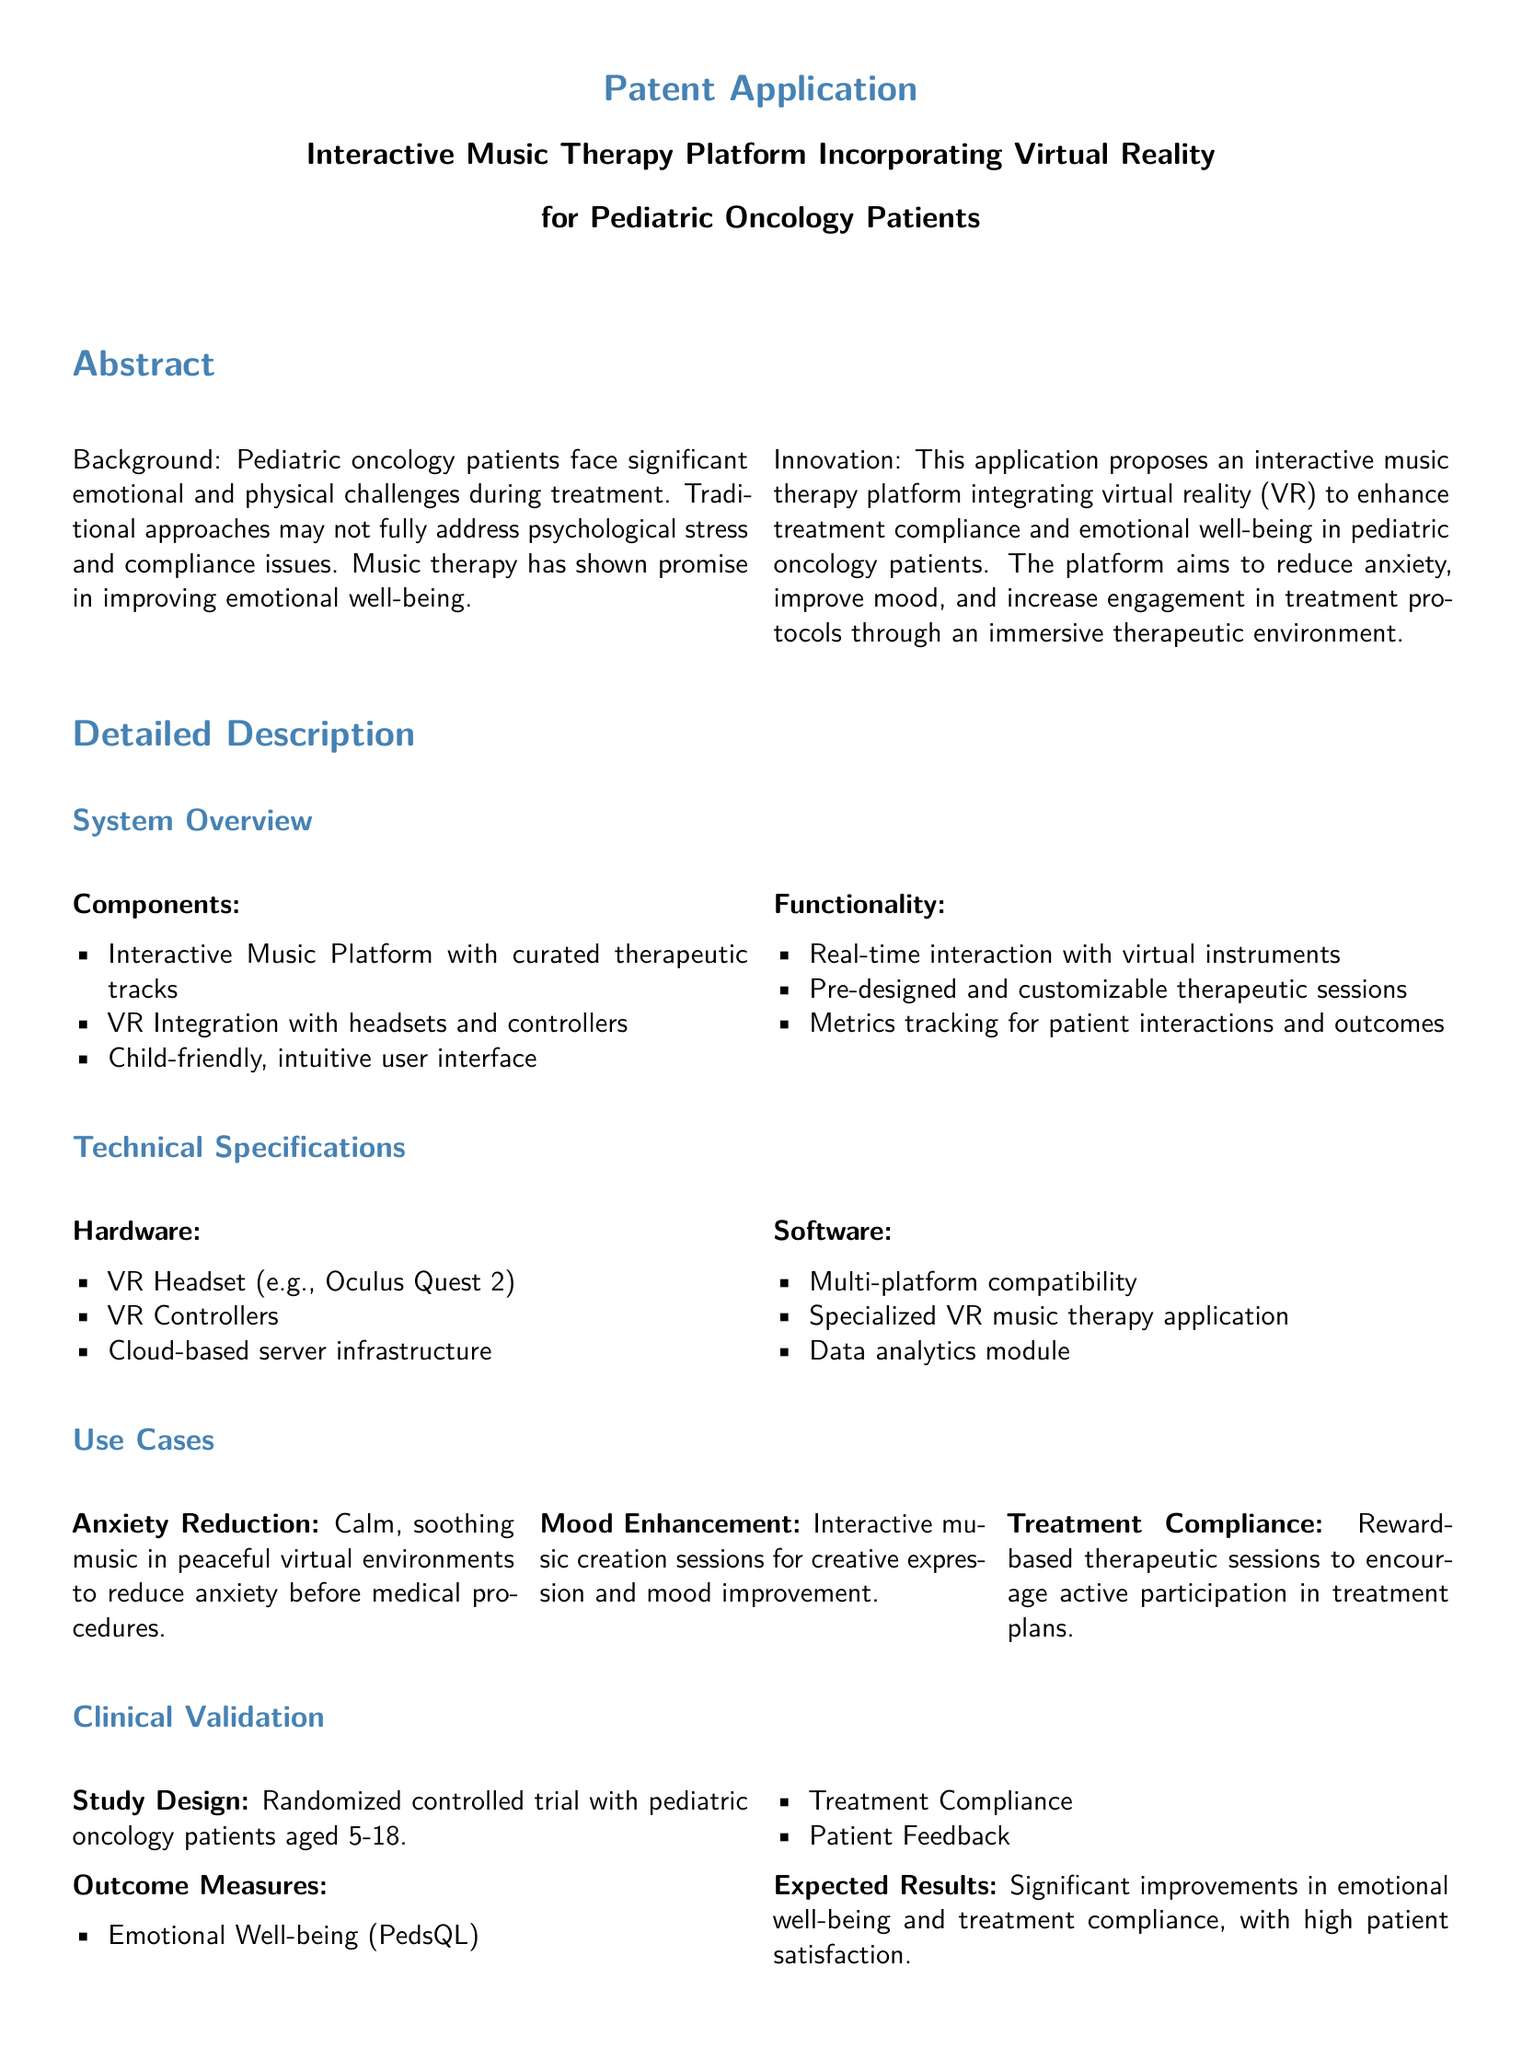What is the target patient age range for the study? The age range specified in the study design is from 5 to 18 years old.
Answer: 5-18 What technology is integrated into the music therapy platform? The document states that the platform incorporates virtual reality (VR).
Answer: Virtual reality What is one expected outcome measure? One outcome measure mentioned is emotional well-being, measured by PedsQL.
Answer: Emotional Well-being (PedsQL) What type of trial is being conducted to validate the platform? The study design specified is a randomized controlled trial.
Answer: Randomized controlled trial Name one component of the system overview. The system overview includes an interactive music platform with curated therapeutic tracks.
Answer: Interactive Music Platform What is a proposed use case for the platform? One use case mentioned is anxiety reduction through calming music in peaceful virtual environments.
Answer: Anxiety Reduction What type of feedback will be collected from patients? Patient feedback is mentioned as an outcome measure in the clinical validation section.
Answer: Patient Feedback What is a specific hardware requirement for the platform? The document lists VR Headset (e.g., Oculus Quest 2) as a hardware requirement.
Answer: VR Headset (e.g., Oculus Quest 2) What is the purpose of the interactive music therapy platform? The platform aims to enhance treatment compliance and emotional well-being in pediatric oncology patients.
Answer: Enhance treatment compliance and emotional well-being 